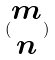<formula> <loc_0><loc_0><loc_500><loc_500>( \begin{matrix} m \\ n \end{matrix} )</formula> 